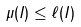<formula> <loc_0><loc_0><loc_500><loc_500>\mu ( I ) \leq \ell ( I )</formula> 